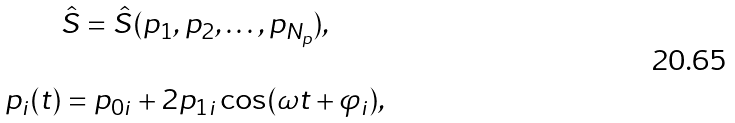<formula> <loc_0><loc_0><loc_500><loc_500>\begin{array} { c } \hat { S } = \hat { S } ( p _ { 1 } , p _ { 2 } , \dots , p _ { N _ { p } } ) , \\ \ \\ p _ { i } ( t ) = p _ { 0 i } + 2 p _ { 1 i } \cos ( \omega t + \varphi _ { i } ) , \end{array}</formula> 